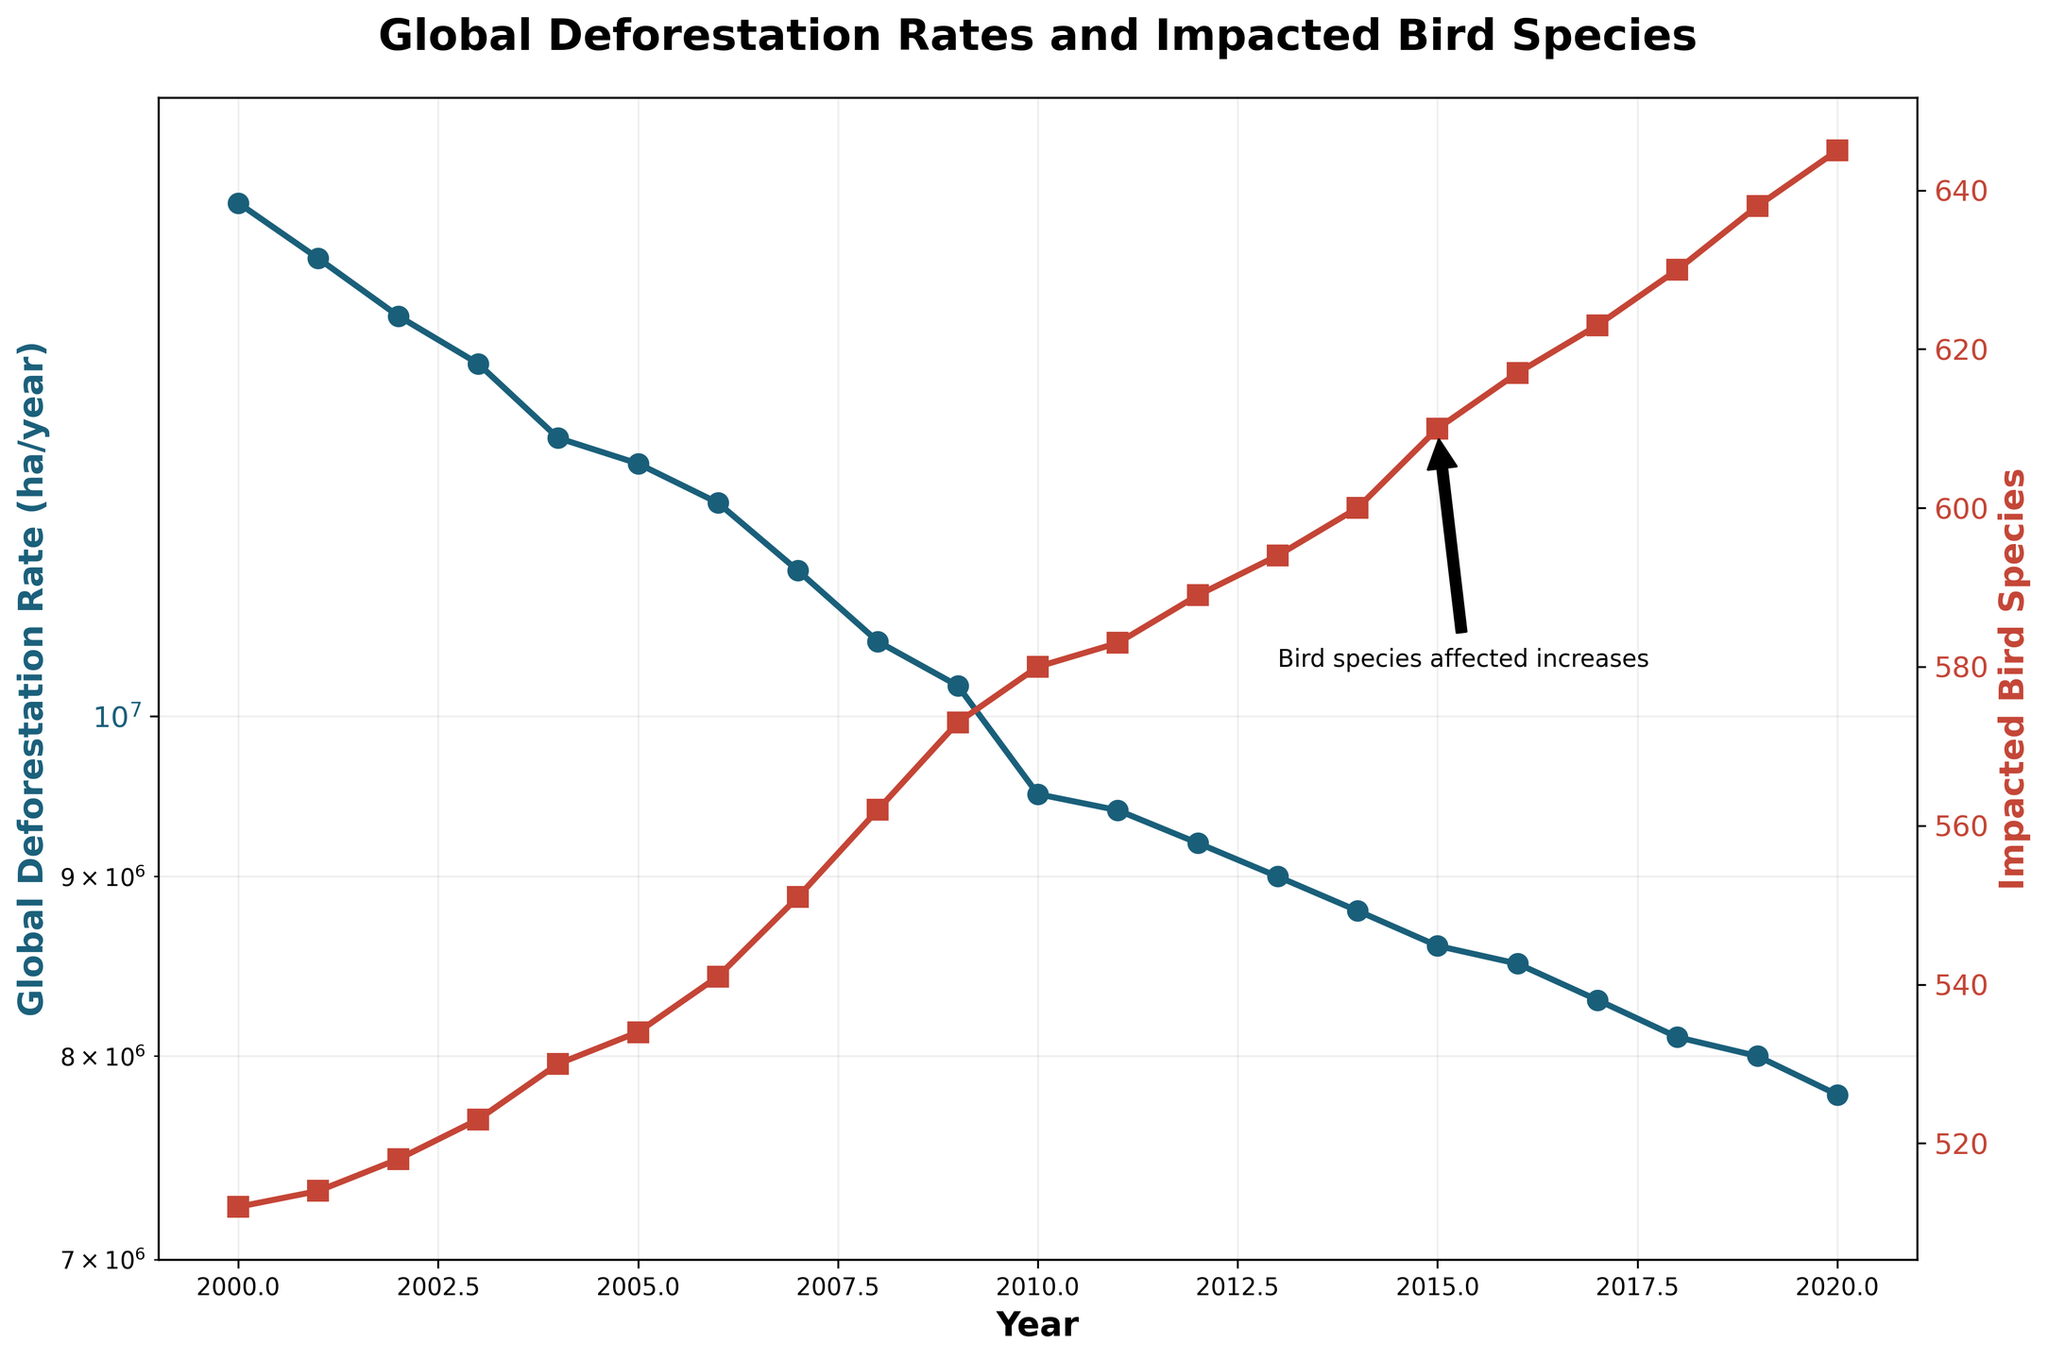What is the title of the plot? Look at the top of the figure where the title is placed, it describes the content of the plot.
Answer: Global Deforestation Rates and Impacted Bird Species What are the colors representing the Global Deforestation Rate and Impacted Bird Species lines? The figure uses different colors for the two lines which can be observed in the plot legend or by visually inspecting the lines.
Answer: Blue and Red How many bird species were impacted in the year 2010? Refer to the red line on the plot at the year 2010 and check the corresponding y-axis value on the right side.
Answer: 580 By how much did the Global Deforestation Rate decrease from 2000 to 2020? Identify the values for the Global Deforestation Rate in 2000 and 2020 from the blue line, then calculate the difference.
Answer: 6,200,000 ha/year In which year did the Impacted Bird Species count reach 600? Look at the red line and find the year where the y-value on the right-hand y-axis reaches 600.
Answer: 2014 What is the trend of the Global Deforestation Rate from 2000 to 2020? Observe the overall direction of the blue line from 2000 to 2020. Is it increasing, decreasing, or stable over time?
Answer: Decreasing Which year had the highest Impacted Bird Species count and what was the count? Identify the peak of the red line which indicates the highest count; verify the year and count associated with this peak.
Answer: 2020, 645 What happened to the Global Deforestation Rate around the year 2010 according to the annotation? Read the annotation text associated with the year 2010 mentioning the deforestation rate trend.
Answer: Deforestation rate decreases By how much did the number of Impacted Bird Species increase from 2005 to 2015? Compare the number of impacted bird species in 2005 and 2015 from the red line and compute the difference.
Answer: 76 